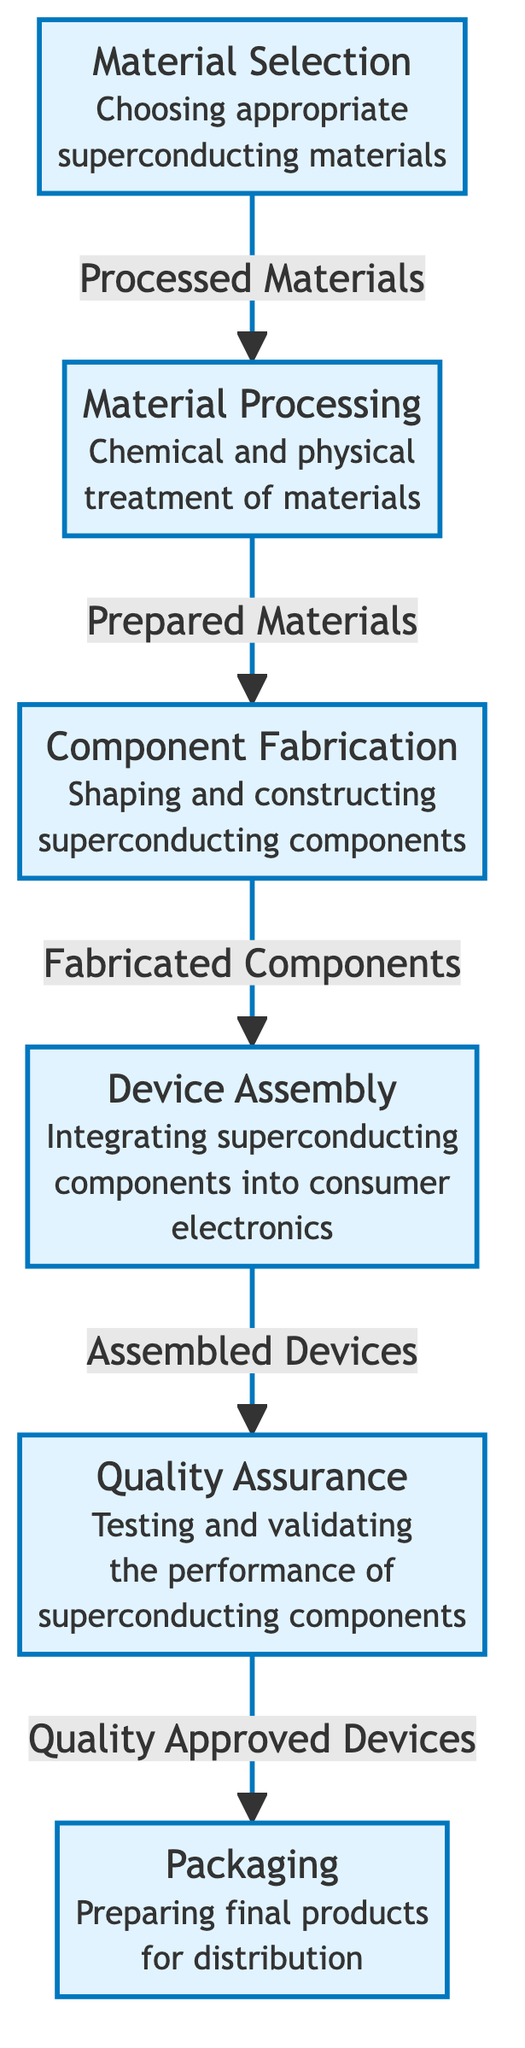What is the first stage in the production process? The first stage depicted in the diagram is "Material Selection", which is where appropriate superconducting materials are chosen.
Answer: Material Selection How many stages are there in the production process? The diagram shows a total of six stages in the production process: Material Selection, Material Processing, Component Fabrication, Device Assembly, Quality Assurance, and Packaging.
Answer: Six What comes after Material Processing? "Component Fabrication" comes after "Material Processing" in the flow of the diagram.
Answer: Component Fabrication Which stage involves integrating superconducting components into consumer electronics? The stage that involves integrating superconducting components into consumer electronics is "Device Assembly."
Answer: Device Assembly What is the output of the Quality Assurance stage? The output of the Quality Assurance stage is "Quality Approved Devices", which signifies that the devices have passed testing and validation.
Answer: Quality Approved Devices What process follows Component Fabrication? Following "Component Fabrication", the next process is "Device Assembly."
Answer: Device Assembly Explain the relationship between Assembly and Quality Assurance. "Assembly" provides "Assembled Devices" as the input to the "Quality Assurance" stage, meaning that the assembled devices must be tested and validated for performance in that stage.
Answer: Assembled Devices What is the final stage in the production process? The final stage described in the diagram is "Packaging," where final products are prepared for distribution.
Answer: Packaging How do materials transition from Fabrication to Assembly? Materials transition from "Fabrication" to "Assembly" as "Fabricated Components," meaning that completed components are then assembled into devices in the following stage.
Answer: Fabricated Components 